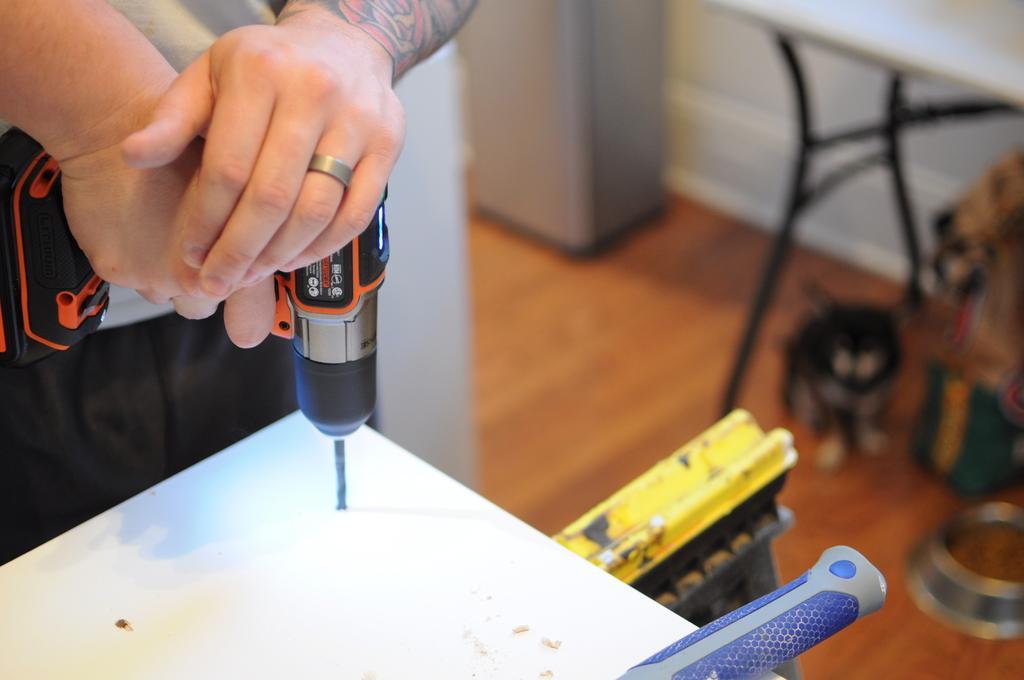How would you summarize this image in a sentence or two? Here we can see a person holding a drilling machine. This is floor and there is a table. This is wall and there is a blur background. 